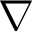Convert formula to latex. <formula><loc_0><loc_0><loc_500><loc_500>\nabla</formula> 